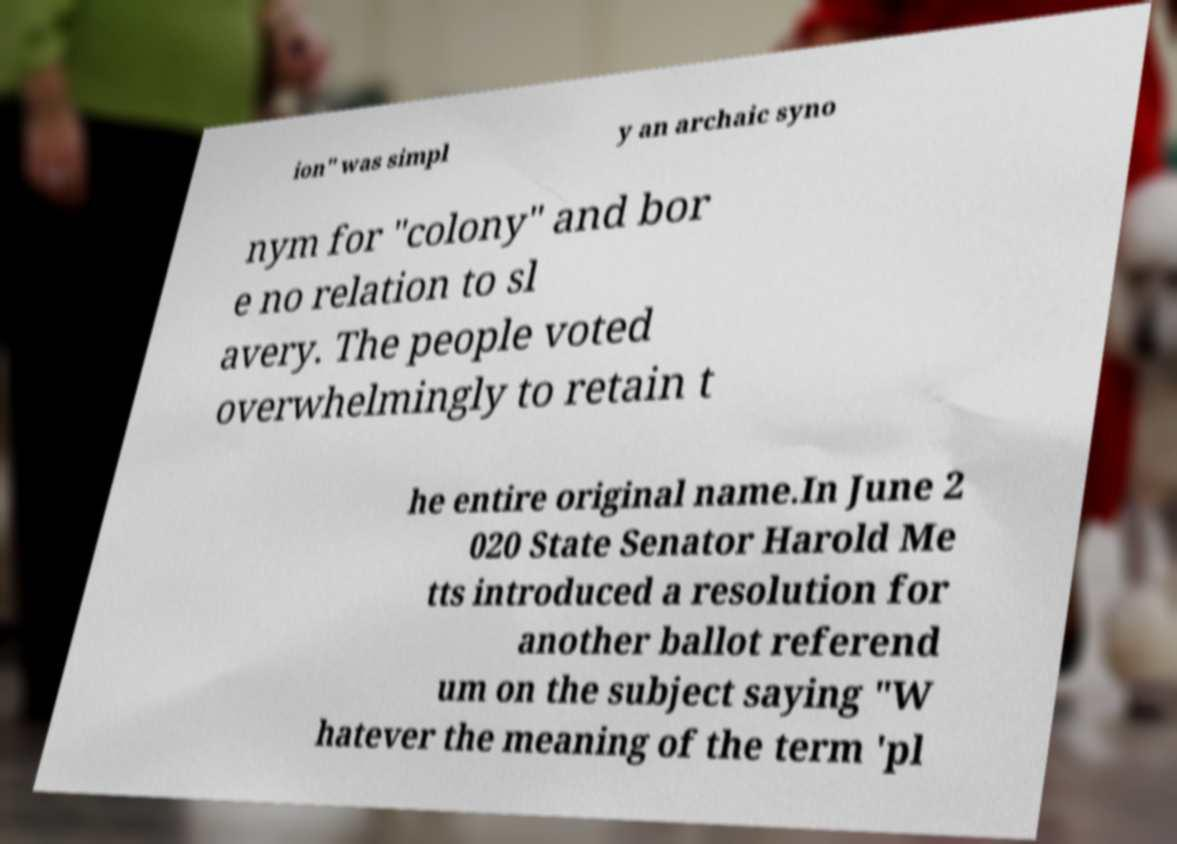Can you accurately transcribe the text from the provided image for me? ion" was simpl y an archaic syno nym for "colony" and bor e no relation to sl avery. The people voted overwhelmingly to retain t he entire original name.In June 2 020 State Senator Harold Me tts introduced a resolution for another ballot referend um on the subject saying "W hatever the meaning of the term 'pl 